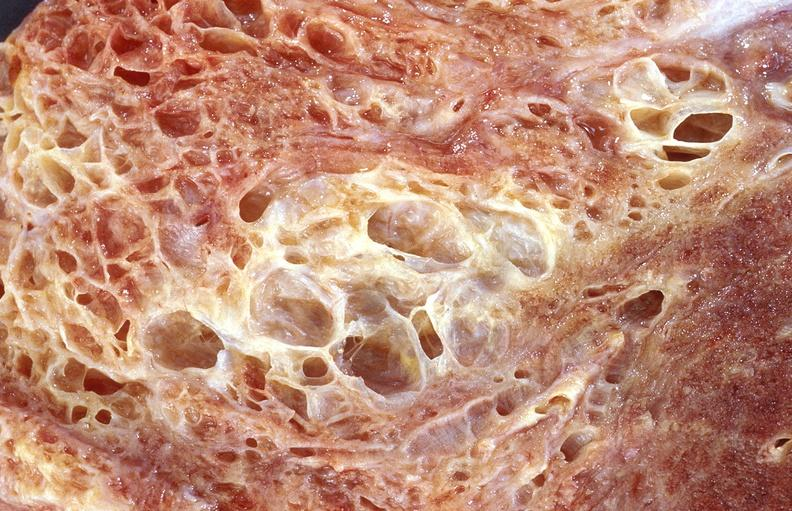does this image show lung fibrosis, scleroderma?
Answer the question using a single word or phrase. Yes 